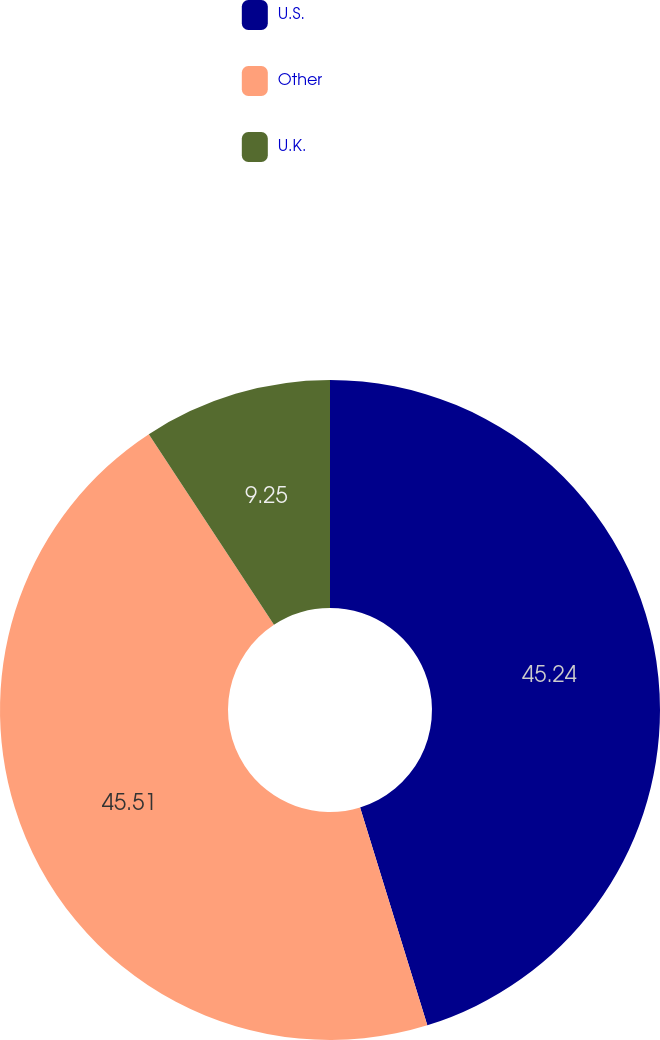<chart> <loc_0><loc_0><loc_500><loc_500><pie_chart><fcel>U.S.<fcel>Other<fcel>U.K.<nl><fcel>45.24%<fcel>45.52%<fcel>9.25%<nl></chart> 